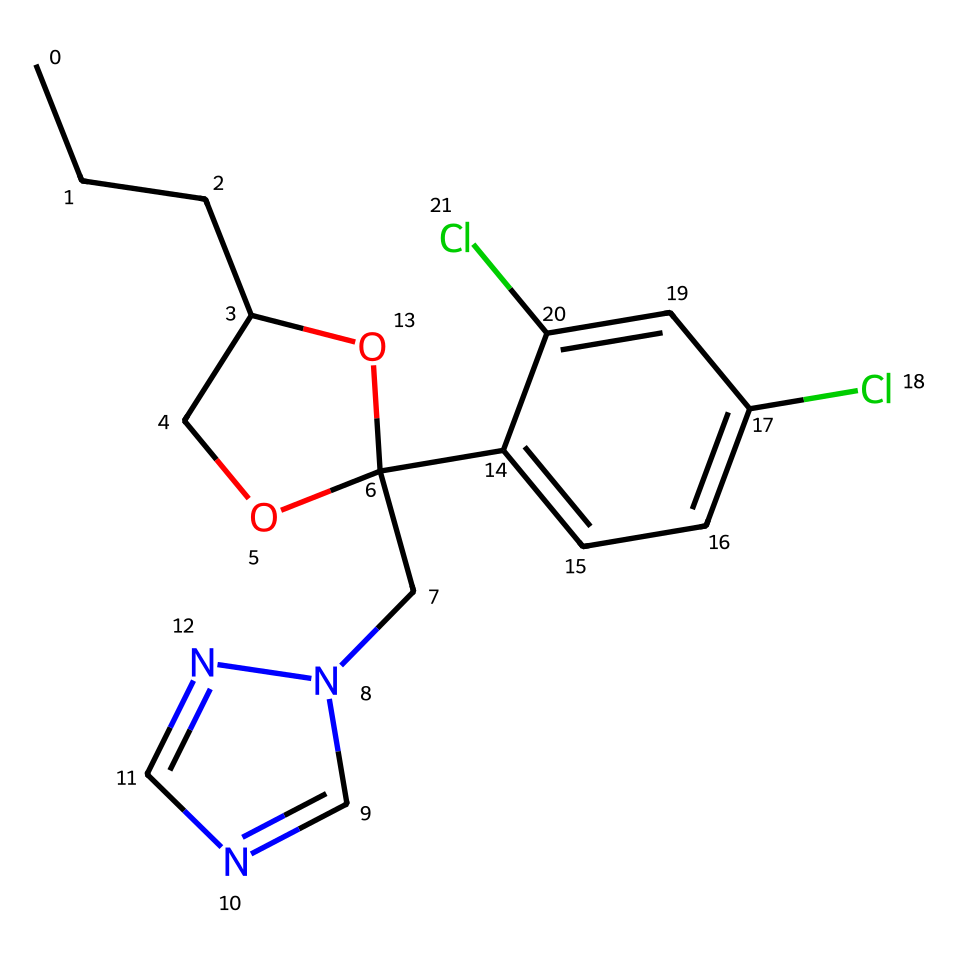What is the primary functional group in propiconazole? The structure includes a hydroxyl group (-OH) indicated by the presence of an oxygen atom bonded to a carbon that is attached to a carbon chain, making it a phenolic compound.
Answer: phenolic How many chlorine atoms are present in propiconazole? By examining the structure, there are two chlorine atoms bonded to different positions on the aromatic ring of the chemical structure.
Answer: two What is the total number of rings in the structure of propiconazole? The SMILES representation shows one cyclic component in addition to the aromatic rings, resulting in two rings in total (one from the cyclic ether and the other from the aromatic system).
Answer: two What type of compound is propiconazole classified as? Since propiconazole acts as a fungicide, it is a derivative of triazole, which is known for its antifungal properties, indicated by the presence of the triazole ring in the structure.
Answer: triazole How many nitrogen atoms are in the structural formula of propiconazole? Upon inspecting the structure, there are two nitrogen atoms present in the triazole ring, confirming the presence of a nitrogen-rich portion of the molecule.
Answer: two 